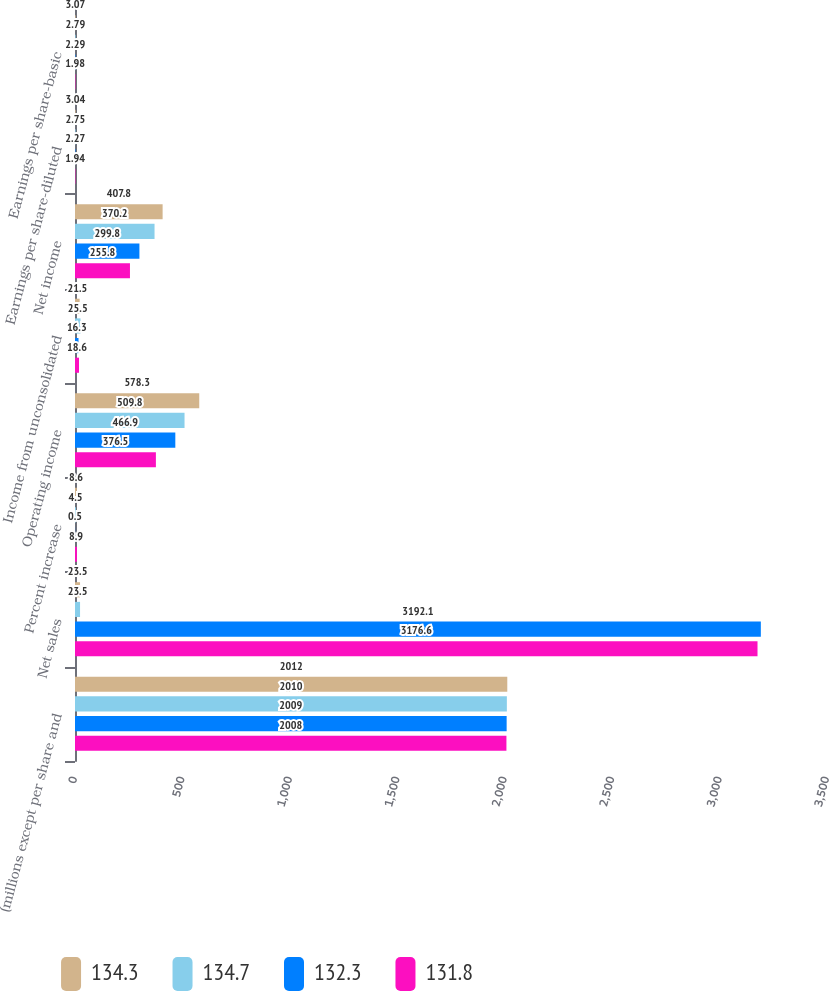Convert chart to OTSL. <chart><loc_0><loc_0><loc_500><loc_500><stacked_bar_chart><ecel><fcel>(millions except per share and<fcel>Net sales<fcel>Percent increase<fcel>Operating income<fcel>Income from unconsolidated<fcel>Net income<fcel>Earnings per share-diluted<fcel>Earnings per share-basic<nl><fcel>134.3<fcel>2012<fcel>23.5<fcel>8.6<fcel>578.3<fcel>21.5<fcel>407.8<fcel>3.04<fcel>3.07<nl><fcel>134.7<fcel>2010<fcel>23.5<fcel>4.5<fcel>509.8<fcel>25.5<fcel>370.2<fcel>2.75<fcel>2.79<nl><fcel>132.3<fcel>2009<fcel>3192.1<fcel>0.5<fcel>466.9<fcel>16.3<fcel>299.8<fcel>2.27<fcel>2.29<nl><fcel>131.8<fcel>2008<fcel>3176.6<fcel>8.9<fcel>376.5<fcel>18.6<fcel>255.8<fcel>1.94<fcel>1.98<nl></chart> 